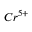Convert formula to latex. <formula><loc_0><loc_0><loc_500><loc_500>C r ^ { 5 + }</formula> 